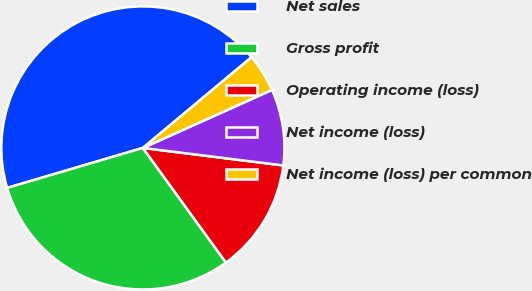Convert chart to OTSL. <chart><loc_0><loc_0><loc_500><loc_500><pie_chart><fcel>Net sales<fcel>Gross profit<fcel>Operating income (loss)<fcel>Net income (loss)<fcel>Net income (loss) per common<nl><fcel>43.49%<fcel>30.42%<fcel>13.05%<fcel>8.7%<fcel>4.35%<nl></chart> 